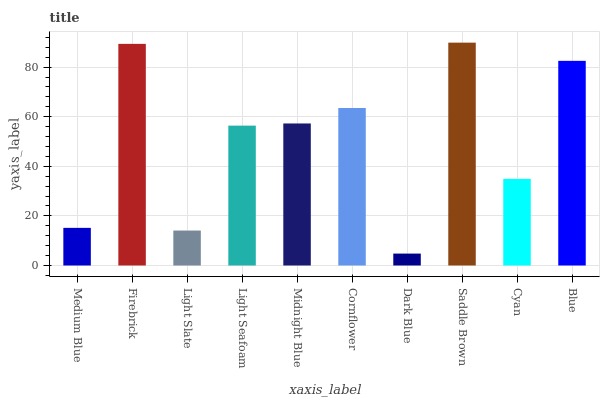Is Dark Blue the minimum?
Answer yes or no. Yes. Is Saddle Brown the maximum?
Answer yes or no. Yes. Is Firebrick the minimum?
Answer yes or no. No. Is Firebrick the maximum?
Answer yes or no. No. Is Firebrick greater than Medium Blue?
Answer yes or no. Yes. Is Medium Blue less than Firebrick?
Answer yes or no. Yes. Is Medium Blue greater than Firebrick?
Answer yes or no. No. Is Firebrick less than Medium Blue?
Answer yes or no. No. Is Midnight Blue the high median?
Answer yes or no. Yes. Is Light Seafoam the low median?
Answer yes or no. Yes. Is Medium Blue the high median?
Answer yes or no. No. Is Medium Blue the low median?
Answer yes or no. No. 